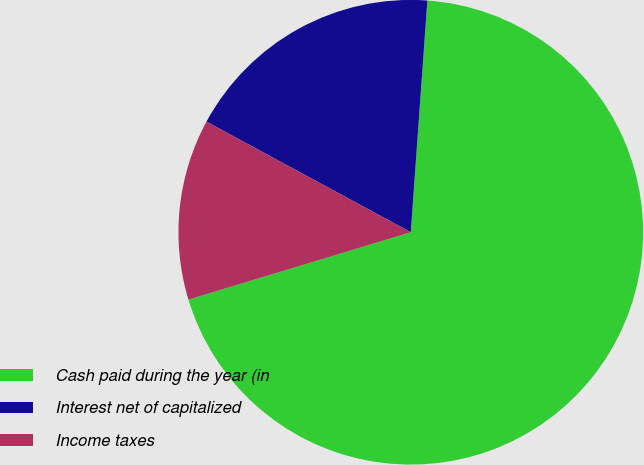<chart> <loc_0><loc_0><loc_500><loc_500><pie_chart><fcel>Cash paid during the year (in<fcel>Interest net of capitalized<fcel>Income taxes<nl><fcel>69.17%<fcel>18.24%<fcel>12.58%<nl></chart> 